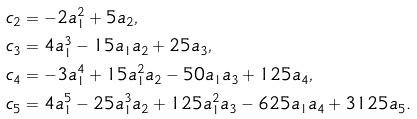Convert formula to latex. <formula><loc_0><loc_0><loc_500><loc_500>c _ { 2 } & = - 2 a _ { 1 } ^ { 2 } + 5 a _ { 2 } , \\ c _ { 3 } & = 4 a _ { 1 } ^ { 3 } - 1 5 a _ { 1 } a _ { 2 } + 2 5 a _ { 3 } , \\ c _ { 4 } & = - 3 a _ { 1 } ^ { 4 } + 1 5 a _ { 1 } ^ { 2 } a _ { 2 } - 5 0 a _ { 1 } a _ { 3 } + 1 2 5 a _ { 4 } , \\ c _ { 5 } & = 4 a _ { 1 } ^ { 5 } - 2 5 a _ { 1 } ^ { 3 } a _ { 2 } + 1 2 5 a _ { 1 } ^ { 2 } a _ { 3 } - 6 2 5 a _ { 1 } a _ { 4 } + 3 1 2 5 a _ { 5 } .</formula> 